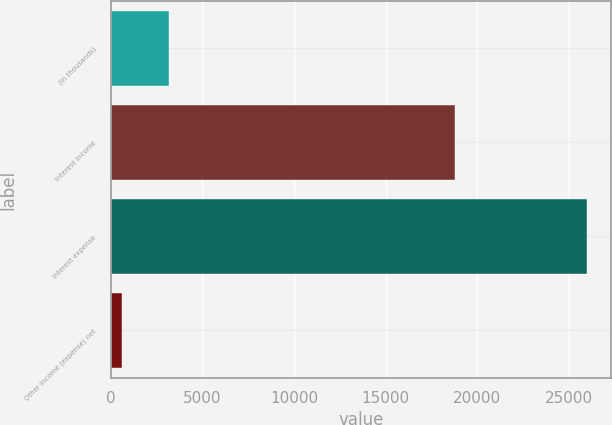<chart> <loc_0><loc_0><loc_500><loc_500><bar_chart><fcel>(In thousands)<fcel>Interest income<fcel>Interest expense<fcel>Other income (expense) net<nl><fcel>3164.1<fcel>18782<fcel>25989<fcel>628<nl></chart> 